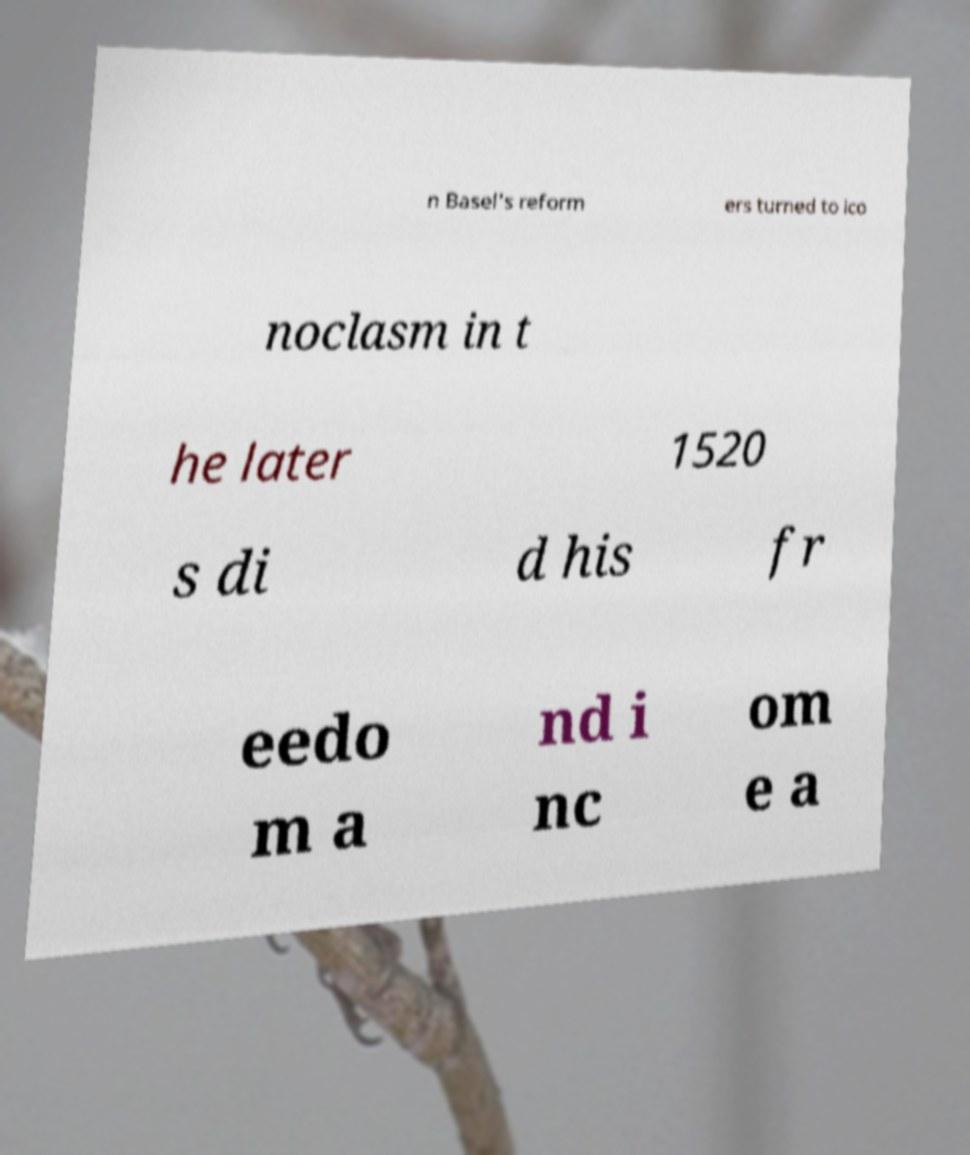Please identify and transcribe the text found in this image. n Basel's reform ers turned to ico noclasm in t he later 1520 s di d his fr eedo m a nd i nc om e a 